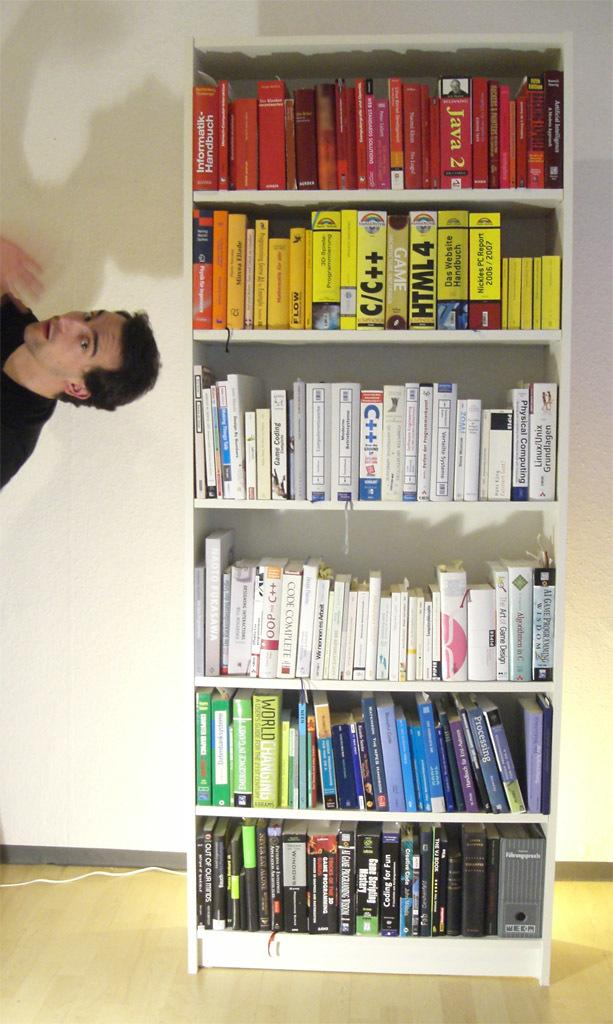<image>
Summarize the visual content of the image. Yellow books about C/C++ and HTML4 sit on a shelf full of color-coded books. 